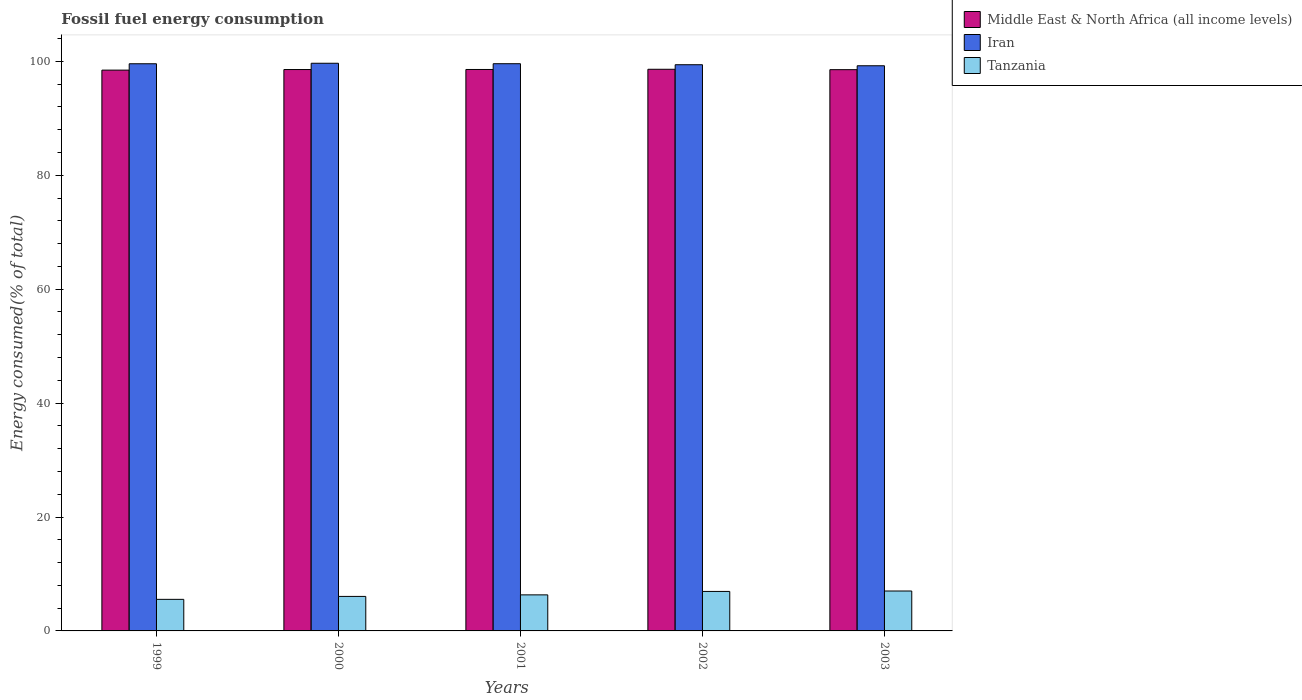How many different coloured bars are there?
Your response must be concise. 3. Are the number of bars per tick equal to the number of legend labels?
Give a very brief answer. Yes. Are the number of bars on each tick of the X-axis equal?
Give a very brief answer. Yes. In how many cases, is the number of bars for a given year not equal to the number of legend labels?
Ensure brevity in your answer.  0. What is the percentage of energy consumed in Iran in 1999?
Provide a short and direct response. 99.58. Across all years, what is the maximum percentage of energy consumed in Middle East & North Africa (all income levels)?
Your answer should be very brief. 98.61. Across all years, what is the minimum percentage of energy consumed in Middle East & North Africa (all income levels)?
Your answer should be compact. 98.46. In which year was the percentage of energy consumed in Tanzania maximum?
Your answer should be very brief. 2003. In which year was the percentage of energy consumed in Middle East & North Africa (all income levels) minimum?
Your answer should be very brief. 1999. What is the total percentage of energy consumed in Iran in the graph?
Keep it short and to the point. 497.46. What is the difference between the percentage of energy consumed in Tanzania in 2001 and that in 2002?
Your answer should be compact. -0.6. What is the difference between the percentage of energy consumed in Iran in 2003 and the percentage of energy consumed in Middle East & North Africa (all income levels) in 1999?
Give a very brief answer. 0.76. What is the average percentage of energy consumed in Iran per year?
Ensure brevity in your answer.  99.49. In the year 2002, what is the difference between the percentage of energy consumed in Iran and percentage of energy consumed in Tanzania?
Your response must be concise. 92.47. What is the ratio of the percentage of energy consumed in Iran in 2001 to that in 2002?
Your answer should be compact. 1. Is the difference between the percentage of energy consumed in Iran in 2001 and 2003 greater than the difference between the percentage of energy consumed in Tanzania in 2001 and 2003?
Your answer should be compact. Yes. What is the difference between the highest and the second highest percentage of energy consumed in Iran?
Offer a very short reply. 0.08. What is the difference between the highest and the lowest percentage of energy consumed in Iran?
Make the answer very short. 0.44. What does the 1st bar from the left in 1999 represents?
Your answer should be compact. Middle East & North Africa (all income levels). What does the 3rd bar from the right in 1999 represents?
Provide a short and direct response. Middle East & North Africa (all income levels). Are all the bars in the graph horizontal?
Provide a succinct answer. No. Are the values on the major ticks of Y-axis written in scientific E-notation?
Your answer should be compact. No. Does the graph contain grids?
Offer a very short reply. No. Where does the legend appear in the graph?
Your response must be concise. Top right. How are the legend labels stacked?
Your response must be concise. Vertical. What is the title of the graph?
Your answer should be compact. Fossil fuel energy consumption. What is the label or title of the Y-axis?
Offer a very short reply. Energy consumed(% of total). What is the Energy consumed(% of total) of Middle East & North Africa (all income levels) in 1999?
Your response must be concise. 98.46. What is the Energy consumed(% of total) of Iran in 1999?
Your answer should be very brief. 99.58. What is the Energy consumed(% of total) in Tanzania in 1999?
Offer a terse response. 5.54. What is the Energy consumed(% of total) of Middle East & North Africa (all income levels) in 2000?
Your response must be concise. 98.56. What is the Energy consumed(% of total) of Iran in 2000?
Ensure brevity in your answer.  99.67. What is the Energy consumed(% of total) in Tanzania in 2000?
Provide a short and direct response. 6.06. What is the Energy consumed(% of total) in Middle East & North Africa (all income levels) in 2001?
Your answer should be compact. 98.57. What is the Energy consumed(% of total) in Iran in 2001?
Provide a short and direct response. 99.58. What is the Energy consumed(% of total) of Tanzania in 2001?
Keep it short and to the point. 6.33. What is the Energy consumed(% of total) of Middle East & North Africa (all income levels) in 2002?
Your answer should be very brief. 98.61. What is the Energy consumed(% of total) in Iran in 2002?
Offer a very short reply. 99.41. What is the Energy consumed(% of total) in Tanzania in 2002?
Give a very brief answer. 6.93. What is the Energy consumed(% of total) in Middle East & North Africa (all income levels) in 2003?
Your answer should be very brief. 98.54. What is the Energy consumed(% of total) in Iran in 2003?
Offer a terse response. 99.23. What is the Energy consumed(% of total) in Tanzania in 2003?
Provide a succinct answer. 7.01. Across all years, what is the maximum Energy consumed(% of total) in Middle East & North Africa (all income levels)?
Your answer should be very brief. 98.61. Across all years, what is the maximum Energy consumed(% of total) in Iran?
Offer a terse response. 99.67. Across all years, what is the maximum Energy consumed(% of total) of Tanzania?
Make the answer very short. 7.01. Across all years, what is the minimum Energy consumed(% of total) in Middle East & North Africa (all income levels)?
Your answer should be very brief. 98.46. Across all years, what is the minimum Energy consumed(% of total) of Iran?
Provide a short and direct response. 99.23. Across all years, what is the minimum Energy consumed(% of total) of Tanzania?
Keep it short and to the point. 5.54. What is the total Energy consumed(% of total) in Middle East & North Africa (all income levels) in the graph?
Give a very brief answer. 492.75. What is the total Energy consumed(% of total) in Iran in the graph?
Ensure brevity in your answer.  497.46. What is the total Energy consumed(% of total) of Tanzania in the graph?
Keep it short and to the point. 31.87. What is the difference between the Energy consumed(% of total) of Middle East & North Africa (all income levels) in 1999 and that in 2000?
Give a very brief answer. -0.1. What is the difference between the Energy consumed(% of total) in Iran in 1999 and that in 2000?
Offer a terse response. -0.09. What is the difference between the Energy consumed(% of total) in Tanzania in 1999 and that in 2000?
Your response must be concise. -0.52. What is the difference between the Energy consumed(% of total) of Middle East & North Africa (all income levels) in 1999 and that in 2001?
Ensure brevity in your answer.  -0.11. What is the difference between the Energy consumed(% of total) of Iran in 1999 and that in 2001?
Keep it short and to the point. -0.01. What is the difference between the Energy consumed(% of total) in Tanzania in 1999 and that in 2001?
Give a very brief answer. -0.79. What is the difference between the Energy consumed(% of total) in Middle East & North Africa (all income levels) in 1999 and that in 2002?
Your answer should be very brief. -0.15. What is the difference between the Energy consumed(% of total) in Iran in 1999 and that in 2002?
Ensure brevity in your answer.  0.17. What is the difference between the Energy consumed(% of total) in Tanzania in 1999 and that in 2002?
Your answer should be very brief. -1.39. What is the difference between the Energy consumed(% of total) in Middle East & North Africa (all income levels) in 1999 and that in 2003?
Ensure brevity in your answer.  -0.08. What is the difference between the Energy consumed(% of total) in Iran in 1999 and that in 2003?
Keep it short and to the point. 0.35. What is the difference between the Energy consumed(% of total) of Tanzania in 1999 and that in 2003?
Provide a succinct answer. -1.47. What is the difference between the Energy consumed(% of total) in Middle East & North Africa (all income levels) in 2000 and that in 2001?
Give a very brief answer. -0.01. What is the difference between the Energy consumed(% of total) of Iran in 2000 and that in 2001?
Make the answer very short. 0.08. What is the difference between the Energy consumed(% of total) of Tanzania in 2000 and that in 2001?
Offer a very short reply. -0.27. What is the difference between the Energy consumed(% of total) of Middle East & North Africa (all income levels) in 2000 and that in 2002?
Ensure brevity in your answer.  -0.05. What is the difference between the Energy consumed(% of total) of Iran in 2000 and that in 2002?
Provide a short and direct response. 0.26. What is the difference between the Energy consumed(% of total) of Tanzania in 2000 and that in 2002?
Your answer should be compact. -0.88. What is the difference between the Energy consumed(% of total) in Middle East & North Africa (all income levels) in 2000 and that in 2003?
Make the answer very short. 0.02. What is the difference between the Energy consumed(% of total) of Iran in 2000 and that in 2003?
Offer a terse response. 0.44. What is the difference between the Energy consumed(% of total) in Tanzania in 2000 and that in 2003?
Provide a short and direct response. -0.95. What is the difference between the Energy consumed(% of total) in Middle East & North Africa (all income levels) in 2001 and that in 2002?
Keep it short and to the point. -0.03. What is the difference between the Energy consumed(% of total) in Iran in 2001 and that in 2002?
Make the answer very short. 0.18. What is the difference between the Energy consumed(% of total) in Tanzania in 2001 and that in 2002?
Give a very brief answer. -0.6. What is the difference between the Energy consumed(% of total) in Middle East & North Africa (all income levels) in 2001 and that in 2003?
Your answer should be compact. 0.04. What is the difference between the Energy consumed(% of total) in Iran in 2001 and that in 2003?
Provide a succinct answer. 0.36. What is the difference between the Energy consumed(% of total) in Tanzania in 2001 and that in 2003?
Ensure brevity in your answer.  -0.68. What is the difference between the Energy consumed(% of total) of Middle East & North Africa (all income levels) in 2002 and that in 2003?
Offer a terse response. 0.07. What is the difference between the Energy consumed(% of total) of Iran in 2002 and that in 2003?
Make the answer very short. 0.18. What is the difference between the Energy consumed(% of total) of Tanzania in 2002 and that in 2003?
Your answer should be very brief. -0.07. What is the difference between the Energy consumed(% of total) of Middle East & North Africa (all income levels) in 1999 and the Energy consumed(% of total) of Iran in 2000?
Ensure brevity in your answer.  -1.2. What is the difference between the Energy consumed(% of total) in Middle East & North Africa (all income levels) in 1999 and the Energy consumed(% of total) in Tanzania in 2000?
Your response must be concise. 92.4. What is the difference between the Energy consumed(% of total) in Iran in 1999 and the Energy consumed(% of total) in Tanzania in 2000?
Make the answer very short. 93.52. What is the difference between the Energy consumed(% of total) of Middle East & North Africa (all income levels) in 1999 and the Energy consumed(% of total) of Iran in 2001?
Your response must be concise. -1.12. What is the difference between the Energy consumed(% of total) of Middle East & North Africa (all income levels) in 1999 and the Energy consumed(% of total) of Tanzania in 2001?
Your answer should be very brief. 92.13. What is the difference between the Energy consumed(% of total) in Iran in 1999 and the Energy consumed(% of total) in Tanzania in 2001?
Keep it short and to the point. 93.25. What is the difference between the Energy consumed(% of total) of Middle East & North Africa (all income levels) in 1999 and the Energy consumed(% of total) of Iran in 2002?
Your answer should be very brief. -0.95. What is the difference between the Energy consumed(% of total) in Middle East & North Africa (all income levels) in 1999 and the Energy consumed(% of total) in Tanzania in 2002?
Provide a short and direct response. 91.53. What is the difference between the Energy consumed(% of total) in Iran in 1999 and the Energy consumed(% of total) in Tanzania in 2002?
Ensure brevity in your answer.  92.64. What is the difference between the Energy consumed(% of total) of Middle East & North Africa (all income levels) in 1999 and the Energy consumed(% of total) of Iran in 2003?
Keep it short and to the point. -0.76. What is the difference between the Energy consumed(% of total) of Middle East & North Africa (all income levels) in 1999 and the Energy consumed(% of total) of Tanzania in 2003?
Provide a short and direct response. 91.45. What is the difference between the Energy consumed(% of total) in Iran in 1999 and the Energy consumed(% of total) in Tanzania in 2003?
Offer a very short reply. 92.57. What is the difference between the Energy consumed(% of total) in Middle East & North Africa (all income levels) in 2000 and the Energy consumed(% of total) in Iran in 2001?
Your response must be concise. -1.02. What is the difference between the Energy consumed(% of total) of Middle East & North Africa (all income levels) in 2000 and the Energy consumed(% of total) of Tanzania in 2001?
Your answer should be compact. 92.23. What is the difference between the Energy consumed(% of total) in Iran in 2000 and the Energy consumed(% of total) in Tanzania in 2001?
Offer a terse response. 93.34. What is the difference between the Energy consumed(% of total) in Middle East & North Africa (all income levels) in 2000 and the Energy consumed(% of total) in Iran in 2002?
Offer a terse response. -0.84. What is the difference between the Energy consumed(% of total) of Middle East & North Africa (all income levels) in 2000 and the Energy consumed(% of total) of Tanzania in 2002?
Your answer should be compact. 91.63. What is the difference between the Energy consumed(% of total) of Iran in 2000 and the Energy consumed(% of total) of Tanzania in 2002?
Offer a terse response. 92.73. What is the difference between the Energy consumed(% of total) of Middle East & North Africa (all income levels) in 2000 and the Energy consumed(% of total) of Iran in 2003?
Ensure brevity in your answer.  -0.66. What is the difference between the Energy consumed(% of total) in Middle East & North Africa (all income levels) in 2000 and the Energy consumed(% of total) in Tanzania in 2003?
Give a very brief answer. 91.56. What is the difference between the Energy consumed(% of total) in Iran in 2000 and the Energy consumed(% of total) in Tanzania in 2003?
Provide a succinct answer. 92.66. What is the difference between the Energy consumed(% of total) of Middle East & North Africa (all income levels) in 2001 and the Energy consumed(% of total) of Iran in 2002?
Provide a succinct answer. -0.83. What is the difference between the Energy consumed(% of total) of Middle East & North Africa (all income levels) in 2001 and the Energy consumed(% of total) of Tanzania in 2002?
Your answer should be compact. 91.64. What is the difference between the Energy consumed(% of total) in Iran in 2001 and the Energy consumed(% of total) in Tanzania in 2002?
Make the answer very short. 92.65. What is the difference between the Energy consumed(% of total) of Middle East & North Africa (all income levels) in 2001 and the Energy consumed(% of total) of Iran in 2003?
Give a very brief answer. -0.65. What is the difference between the Energy consumed(% of total) of Middle East & North Africa (all income levels) in 2001 and the Energy consumed(% of total) of Tanzania in 2003?
Your answer should be compact. 91.57. What is the difference between the Energy consumed(% of total) of Iran in 2001 and the Energy consumed(% of total) of Tanzania in 2003?
Provide a short and direct response. 92.58. What is the difference between the Energy consumed(% of total) in Middle East & North Africa (all income levels) in 2002 and the Energy consumed(% of total) in Iran in 2003?
Offer a terse response. -0.62. What is the difference between the Energy consumed(% of total) of Middle East & North Africa (all income levels) in 2002 and the Energy consumed(% of total) of Tanzania in 2003?
Your response must be concise. 91.6. What is the difference between the Energy consumed(% of total) in Iran in 2002 and the Energy consumed(% of total) in Tanzania in 2003?
Provide a short and direct response. 92.4. What is the average Energy consumed(% of total) in Middle East & North Africa (all income levels) per year?
Provide a succinct answer. 98.55. What is the average Energy consumed(% of total) of Iran per year?
Provide a short and direct response. 99.49. What is the average Energy consumed(% of total) in Tanzania per year?
Provide a short and direct response. 6.37. In the year 1999, what is the difference between the Energy consumed(% of total) in Middle East & North Africa (all income levels) and Energy consumed(% of total) in Iran?
Give a very brief answer. -1.11. In the year 1999, what is the difference between the Energy consumed(% of total) of Middle East & North Africa (all income levels) and Energy consumed(% of total) of Tanzania?
Your answer should be very brief. 92.92. In the year 1999, what is the difference between the Energy consumed(% of total) in Iran and Energy consumed(% of total) in Tanzania?
Provide a succinct answer. 94.03. In the year 2000, what is the difference between the Energy consumed(% of total) in Middle East & North Africa (all income levels) and Energy consumed(% of total) in Iran?
Make the answer very short. -1.1. In the year 2000, what is the difference between the Energy consumed(% of total) of Middle East & North Africa (all income levels) and Energy consumed(% of total) of Tanzania?
Your answer should be very brief. 92.51. In the year 2000, what is the difference between the Energy consumed(% of total) in Iran and Energy consumed(% of total) in Tanzania?
Ensure brevity in your answer.  93.61. In the year 2001, what is the difference between the Energy consumed(% of total) of Middle East & North Africa (all income levels) and Energy consumed(% of total) of Iran?
Your answer should be compact. -1.01. In the year 2001, what is the difference between the Energy consumed(% of total) in Middle East & North Africa (all income levels) and Energy consumed(% of total) in Tanzania?
Give a very brief answer. 92.24. In the year 2001, what is the difference between the Energy consumed(% of total) of Iran and Energy consumed(% of total) of Tanzania?
Offer a very short reply. 93.26. In the year 2002, what is the difference between the Energy consumed(% of total) of Middle East & North Africa (all income levels) and Energy consumed(% of total) of Iran?
Provide a succinct answer. -0.8. In the year 2002, what is the difference between the Energy consumed(% of total) in Middle East & North Africa (all income levels) and Energy consumed(% of total) in Tanzania?
Ensure brevity in your answer.  91.68. In the year 2002, what is the difference between the Energy consumed(% of total) in Iran and Energy consumed(% of total) in Tanzania?
Your response must be concise. 92.47. In the year 2003, what is the difference between the Energy consumed(% of total) in Middle East & North Africa (all income levels) and Energy consumed(% of total) in Iran?
Provide a short and direct response. -0.69. In the year 2003, what is the difference between the Energy consumed(% of total) of Middle East & North Africa (all income levels) and Energy consumed(% of total) of Tanzania?
Your answer should be compact. 91.53. In the year 2003, what is the difference between the Energy consumed(% of total) of Iran and Energy consumed(% of total) of Tanzania?
Offer a very short reply. 92.22. What is the ratio of the Energy consumed(% of total) of Middle East & North Africa (all income levels) in 1999 to that in 2000?
Give a very brief answer. 1. What is the ratio of the Energy consumed(% of total) in Tanzania in 1999 to that in 2000?
Provide a short and direct response. 0.91. What is the ratio of the Energy consumed(% of total) in Tanzania in 1999 to that in 2001?
Provide a succinct answer. 0.88. What is the ratio of the Energy consumed(% of total) in Middle East & North Africa (all income levels) in 1999 to that in 2002?
Offer a terse response. 1. What is the ratio of the Energy consumed(% of total) of Tanzania in 1999 to that in 2002?
Ensure brevity in your answer.  0.8. What is the ratio of the Energy consumed(% of total) of Iran in 1999 to that in 2003?
Provide a short and direct response. 1. What is the ratio of the Energy consumed(% of total) in Tanzania in 1999 to that in 2003?
Keep it short and to the point. 0.79. What is the ratio of the Energy consumed(% of total) of Iran in 2000 to that in 2001?
Offer a terse response. 1. What is the ratio of the Energy consumed(% of total) of Tanzania in 2000 to that in 2001?
Your answer should be compact. 0.96. What is the ratio of the Energy consumed(% of total) in Tanzania in 2000 to that in 2002?
Keep it short and to the point. 0.87. What is the ratio of the Energy consumed(% of total) of Middle East & North Africa (all income levels) in 2000 to that in 2003?
Offer a terse response. 1. What is the ratio of the Energy consumed(% of total) of Iran in 2000 to that in 2003?
Ensure brevity in your answer.  1. What is the ratio of the Energy consumed(% of total) in Tanzania in 2000 to that in 2003?
Your response must be concise. 0.86. What is the ratio of the Energy consumed(% of total) in Middle East & North Africa (all income levels) in 2001 to that in 2002?
Offer a very short reply. 1. What is the ratio of the Energy consumed(% of total) in Iran in 2001 to that in 2002?
Offer a very short reply. 1. What is the ratio of the Energy consumed(% of total) in Iran in 2001 to that in 2003?
Your answer should be compact. 1. What is the ratio of the Energy consumed(% of total) in Tanzania in 2001 to that in 2003?
Give a very brief answer. 0.9. What is the difference between the highest and the second highest Energy consumed(% of total) of Middle East & North Africa (all income levels)?
Make the answer very short. 0.03. What is the difference between the highest and the second highest Energy consumed(% of total) in Iran?
Offer a terse response. 0.08. What is the difference between the highest and the second highest Energy consumed(% of total) of Tanzania?
Ensure brevity in your answer.  0.07. What is the difference between the highest and the lowest Energy consumed(% of total) of Middle East & North Africa (all income levels)?
Make the answer very short. 0.15. What is the difference between the highest and the lowest Energy consumed(% of total) in Iran?
Offer a terse response. 0.44. What is the difference between the highest and the lowest Energy consumed(% of total) in Tanzania?
Offer a very short reply. 1.47. 